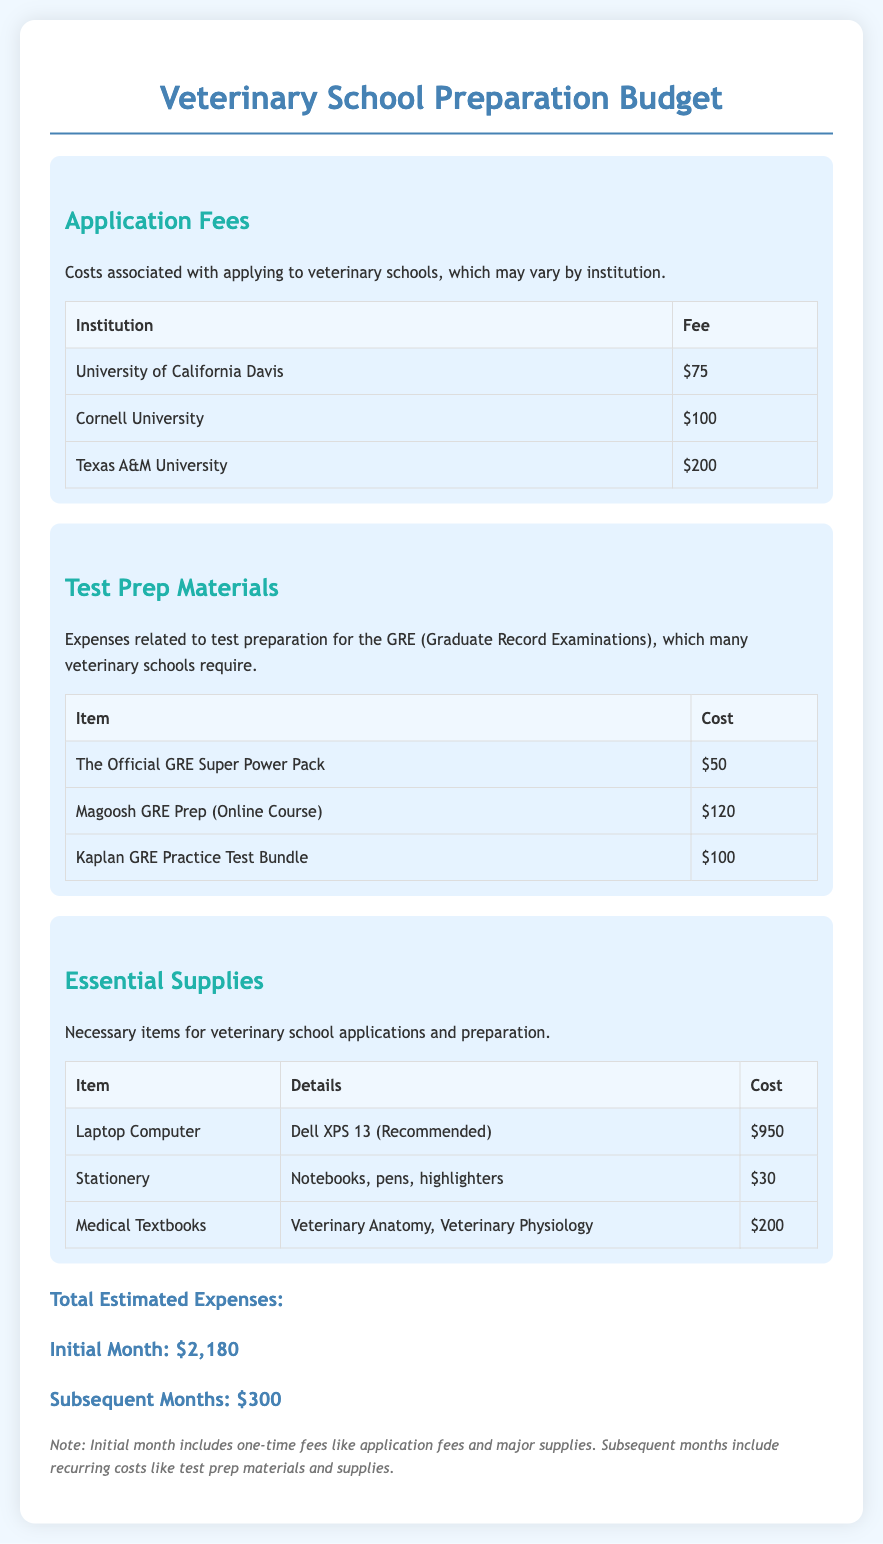What is the total estimated expense for the initial month? The total estimated expense for the initial month is listed in the document as $2,180.
Answer: $2,180 How much is the application fee for Texas A&M University? The document provides the application fee for Texas A&M University as $200.
Answer: $200 What is the cost of the Dell XPS 13 laptop? The document states that the cost of the Dell XPS 13 laptop is $950.
Answer: $950 How much will the subsequent months cost in total? The document indicates that subsequent months will cost $300.
Answer: $300 Which institution has the highest application fee? The document lists the application fees, with Texas A&M University having the highest fee at $200.
Answer: Texas A&M University What item costs $50 in the test prep materials section? The Official GRE Super Power Pack is listed at $50 in the test prep materials section.
Answer: The Official GRE Super Power Pack How many essential supplies are listed in the document? The document lists three essential supplies, which are a laptop, stationery, and medical textbooks.
Answer: Three What is included in the note at the end of the document? The note explains that initial month expenses include one-time fees and supplies, while subsequent months include recurring costs.
Answer: One-time fees and supplies vs. recurring costs Which test preparation item costs the most? The Magoosh GRE Prep (Online Course) costs $120, making it the most expensive test preparation item according to the document.
Answer: Magoosh GRE Prep (Online Course) 